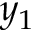Convert formula to latex. <formula><loc_0><loc_0><loc_500><loc_500>y _ { 1 }</formula> 